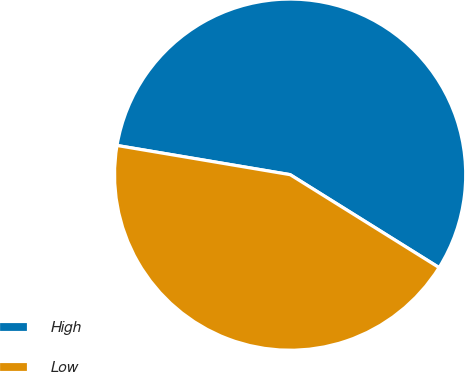Convert chart. <chart><loc_0><loc_0><loc_500><loc_500><pie_chart><fcel>High<fcel>Low<nl><fcel>56.22%<fcel>43.78%<nl></chart> 